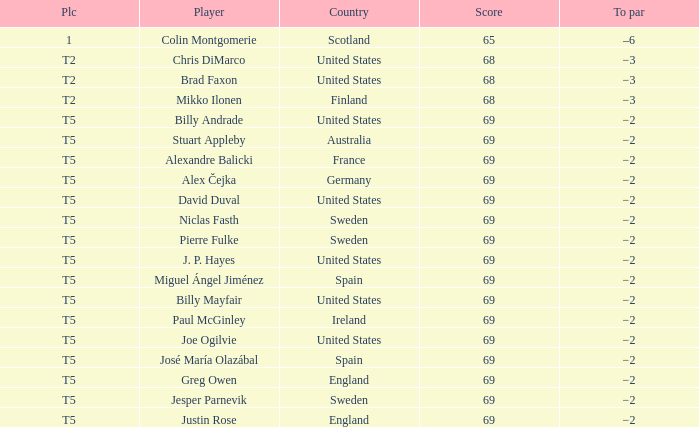What place did Paul McGinley finish in? T5. 